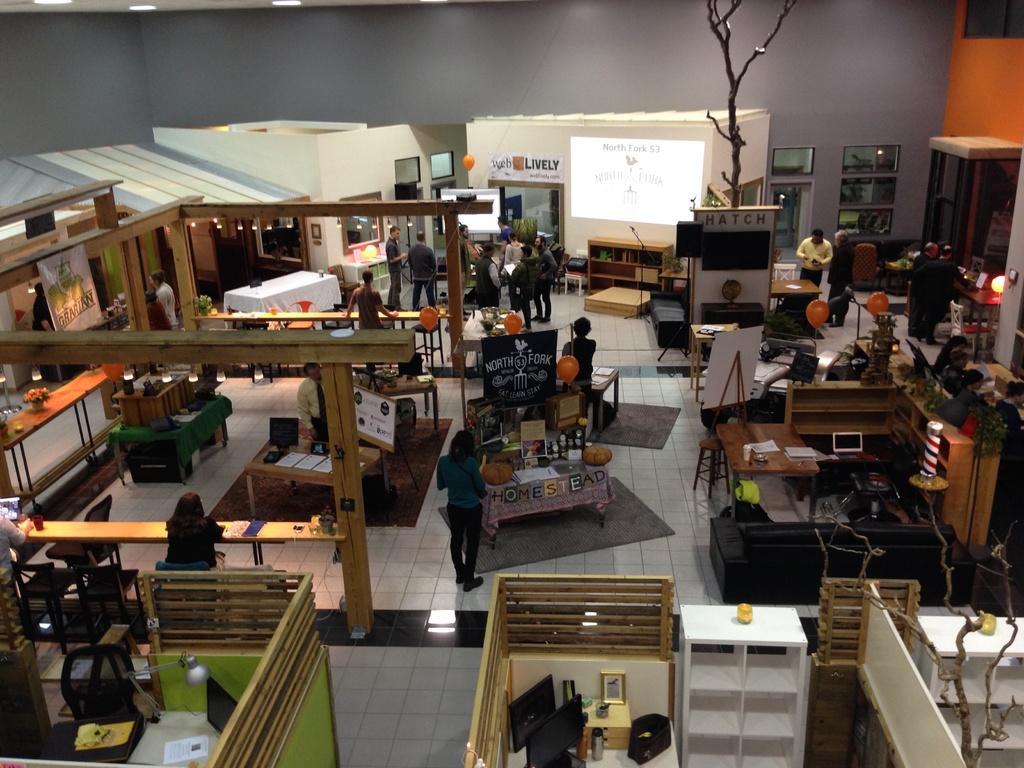Could you give a brief overview of what you see in this image? In this picture this person sitting on the chair. These persons are standing. We can see tables. On the table we can see papers,monitor,photo frame. This is floor. On the background we can see wall,screen,balloon. We can see chairs. 